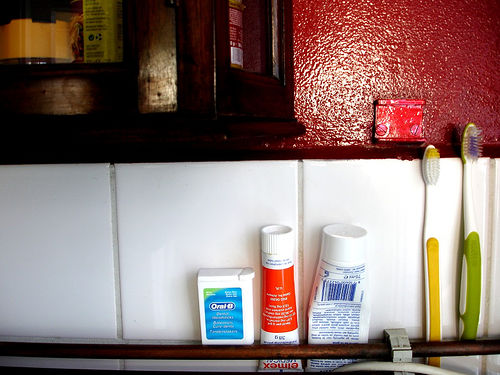Read all the text in this image. Oral B eimex 